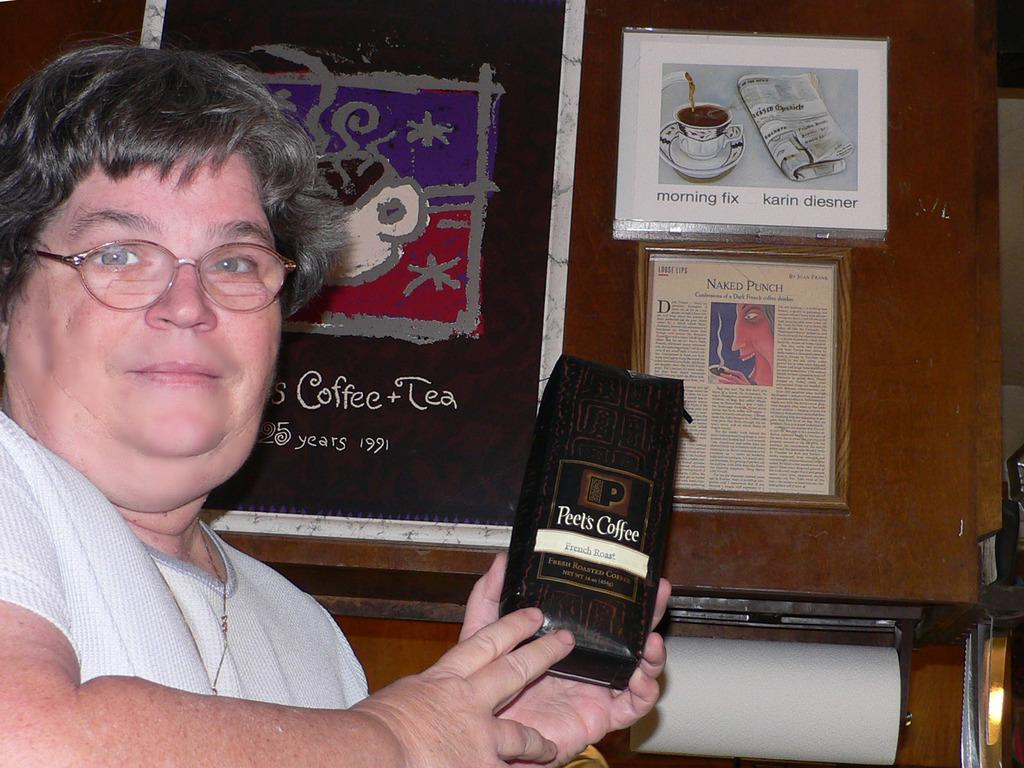Who is present in the image? There is a woman in the image. What is the woman holding in the image? The woman is holding a packet. What accessory is the woman wearing in the image? The woman is wearing glasses. What can be seen in the background of the image? There is a wall in the background of the image. What is on the wall in the image? There are posters on the wall. What is written on the posters? There is text on the posters. What type of word can be seen in the scene? There is no word present in the image; it only contains a woman, a packet, glasses, a wall, posters, and text on the posters. 